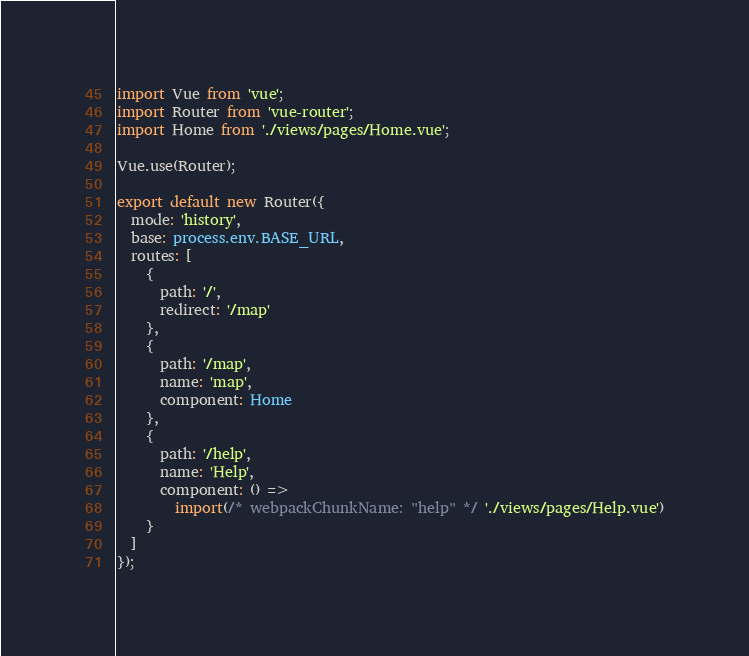Convert code to text. <code><loc_0><loc_0><loc_500><loc_500><_TypeScript_>import Vue from 'vue';
import Router from 'vue-router';
import Home from './views/pages/Home.vue';

Vue.use(Router);

export default new Router({
  mode: 'history',
  base: process.env.BASE_URL,
  routes: [
    {
      path: '/',
      redirect: '/map'
    },
    {
      path: '/map',
      name: 'map',
      component: Home
    },
    {
      path: '/help',
      name: 'Help',
      component: () =>
        import(/* webpackChunkName: "help" */ './views/pages/Help.vue')
    }
  ]
});
</code> 